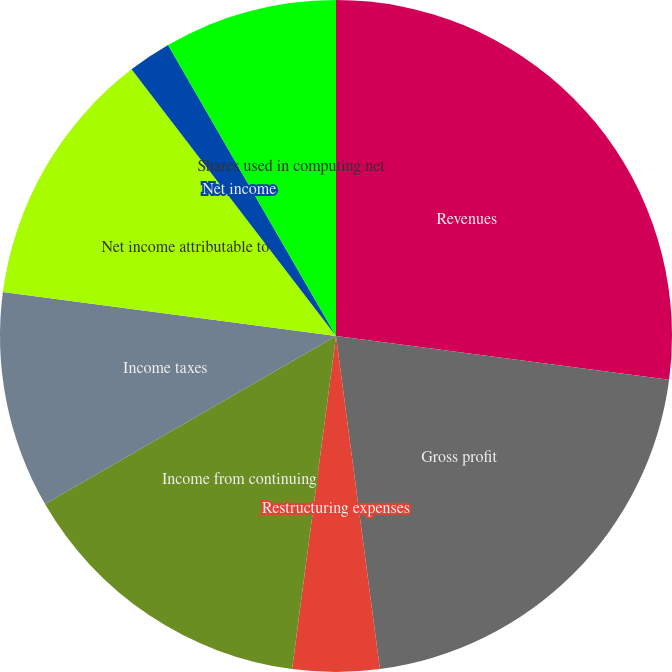Convert chart. <chart><loc_0><loc_0><loc_500><loc_500><pie_chart><fcel>Revenues<fcel>Gross profit<fcel>Restructuring expenses<fcel>Income from continuing<fcel>Income taxes<fcel>Net income attributable to<fcel>Net income<fcel>Shares used in computing net<fcel>Dividends per ordinary share<nl><fcel>27.08%<fcel>20.83%<fcel>4.17%<fcel>14.58%<fcel>10.42%<fcel>12.5%<fcel>2.08%<fcel>8.33%<fcel>0.0%<nl></chart> 